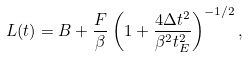Convert formula to latex. <formula><loc_0><loc_0><loc_500><loc_500>L ( t ) = B + \frac { F } { \beta } \left ( 1 + \frac { 4 \Delta t ^ { 2 } } { \beta ^ { 2 } t _ { E } ^ { 2 } } \right ) ^ { - 1 / 2 } ,</formula> 